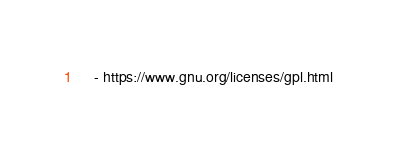<code> <loc_0><loc_0><loc_500><loc_500><_YAML_>    - https://www.gnu.org/licenses/gpl.html
</code> 